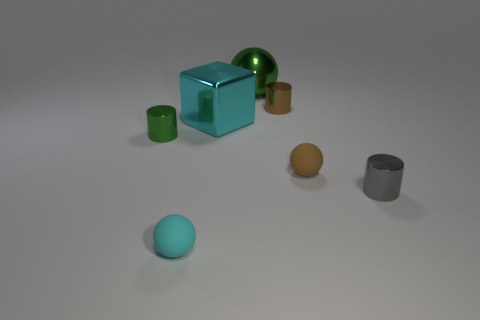Subtract all large green spheres. How many spheres are left? 2 Subtract all brown spheres. How many spheres are left? 2 Subtract all balls. How many objects are left? 4 Add 3 spheres. How many spheres are left? 6 Add 5 red cylinders. How many red cylinders exist? 5 Add 2 big metallic things. How many objects exist? 9 Subtract 0 blue balls. How many objects are left? 7 Subtract 1 cylinders. How many cylinders are left? 2 Subtract all brown cylinders. Subtract all blue balls. How many cylinders are left? 2 Subtract all yellow blocks. How many cyan spheres are left? 1 